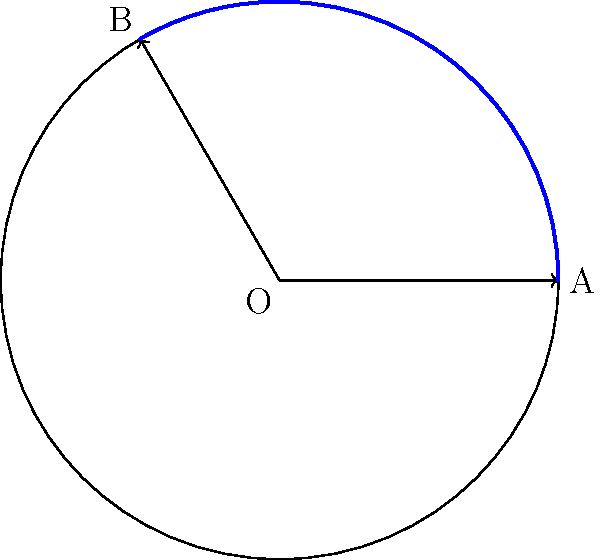At Slavutych-Arena, home of FC Motor Zaporizhzhia, the corner flag poles have a unique curved design. The poles are shaped like circular arcs with a radius of 3 meters. If the central angle of the arc is $\frac{2\pi}{3}$ radians, what is the length of the curved part of the pole? Let's approach this step-by-step:

1) The formula for arc length is: $s = r\theta$
   Where:
   $s$ = arc length
   $r$ = radius of the circle
   $\theta$ = central angle in radians

2) We are given:
   $r = 3$ meters
   $\theta = \frac{2\pi}{3}$ radians

3) Let's substitute these values into the formula:

   $s = r\theta$
   $s = 3 \cdot \frac{2\pi}{3}$

4) Simplify:
   $s = 2\pi$

5) Therefore, the length of the curved part of the pole is $2\pi$ meters.
Answer: $2\pi$ meters 